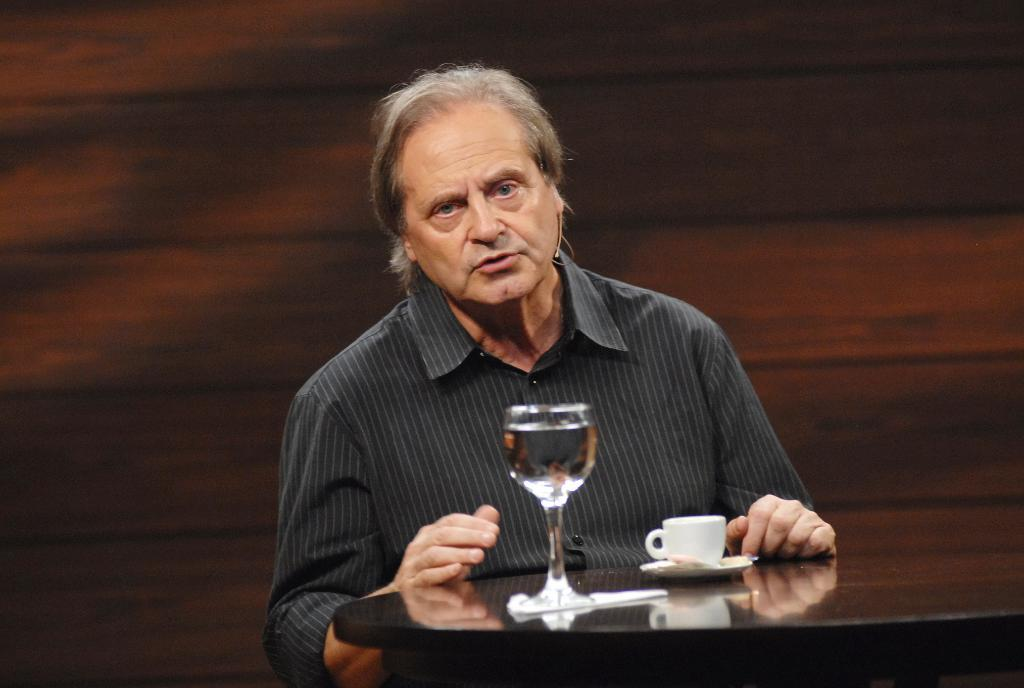Who or what is present in the image? There is a person in the image. What is the person wearing or holding in the image? The person has a microphone on his ear. What piece of furniture is visible in the image? There is a table in the image. What items can be seen on the table? There is a cup and a glass on the table. What type of sound can be heard coming from the drawer in the image? There is no drawer present in the image, so it is not possible to determine what, if any, sound might be heard. 